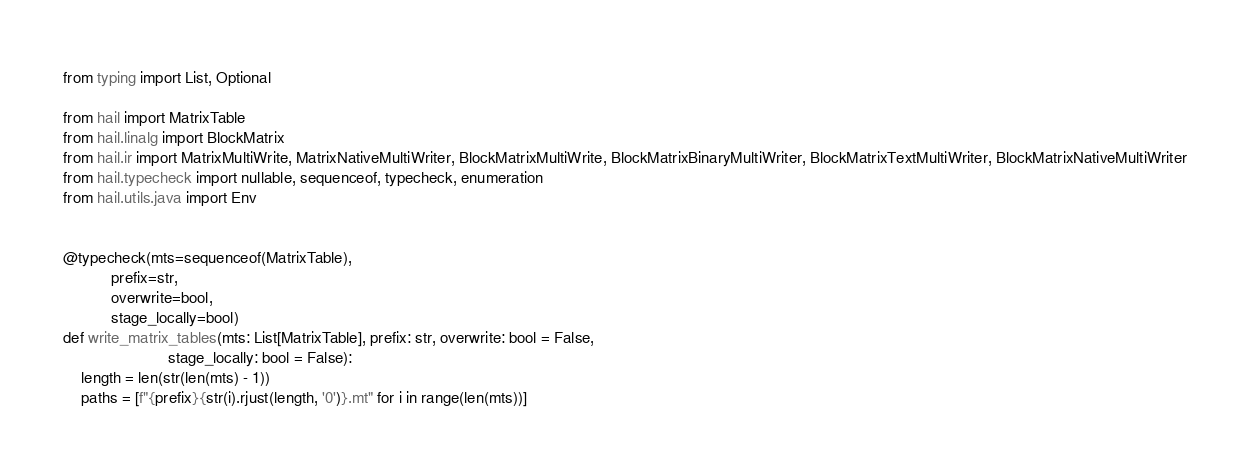Convert code to text. <code><loc_0><loc_0><loc_500><loc_500><_Python_>from typing import List, Optional

from hail import MatrixTable
from hail.linalg import BlockMatrix
from hail.ir import MatrixMultiWrite, MatrixNativeMultiWriter, BlockMatrixMultiWrite, BlockMatrixBinaryMultiWriter, BlockMatrixTextMultiWriter, BlockMatrixNativeMultiWriter
from hail.typecheck import nullable, sequenceof, typecheck, enumeration
from hail.utils.java import Env


@typecheck(mts=sequenceof(MatrixTable),
           prefix=str,
           overwrite=bool,
           stage_locally=bool)
def write_matrix_tables(mts: List[MatrixTable], prefix: str, overwrite: bool = False,
                        stage_locally: bool = False):
    length = len(str(len(mts) - 1))
    paths = [f"{prefix}{str(i).rjust(length, '0')}.mt" for i in range(len(mts))]</code> 